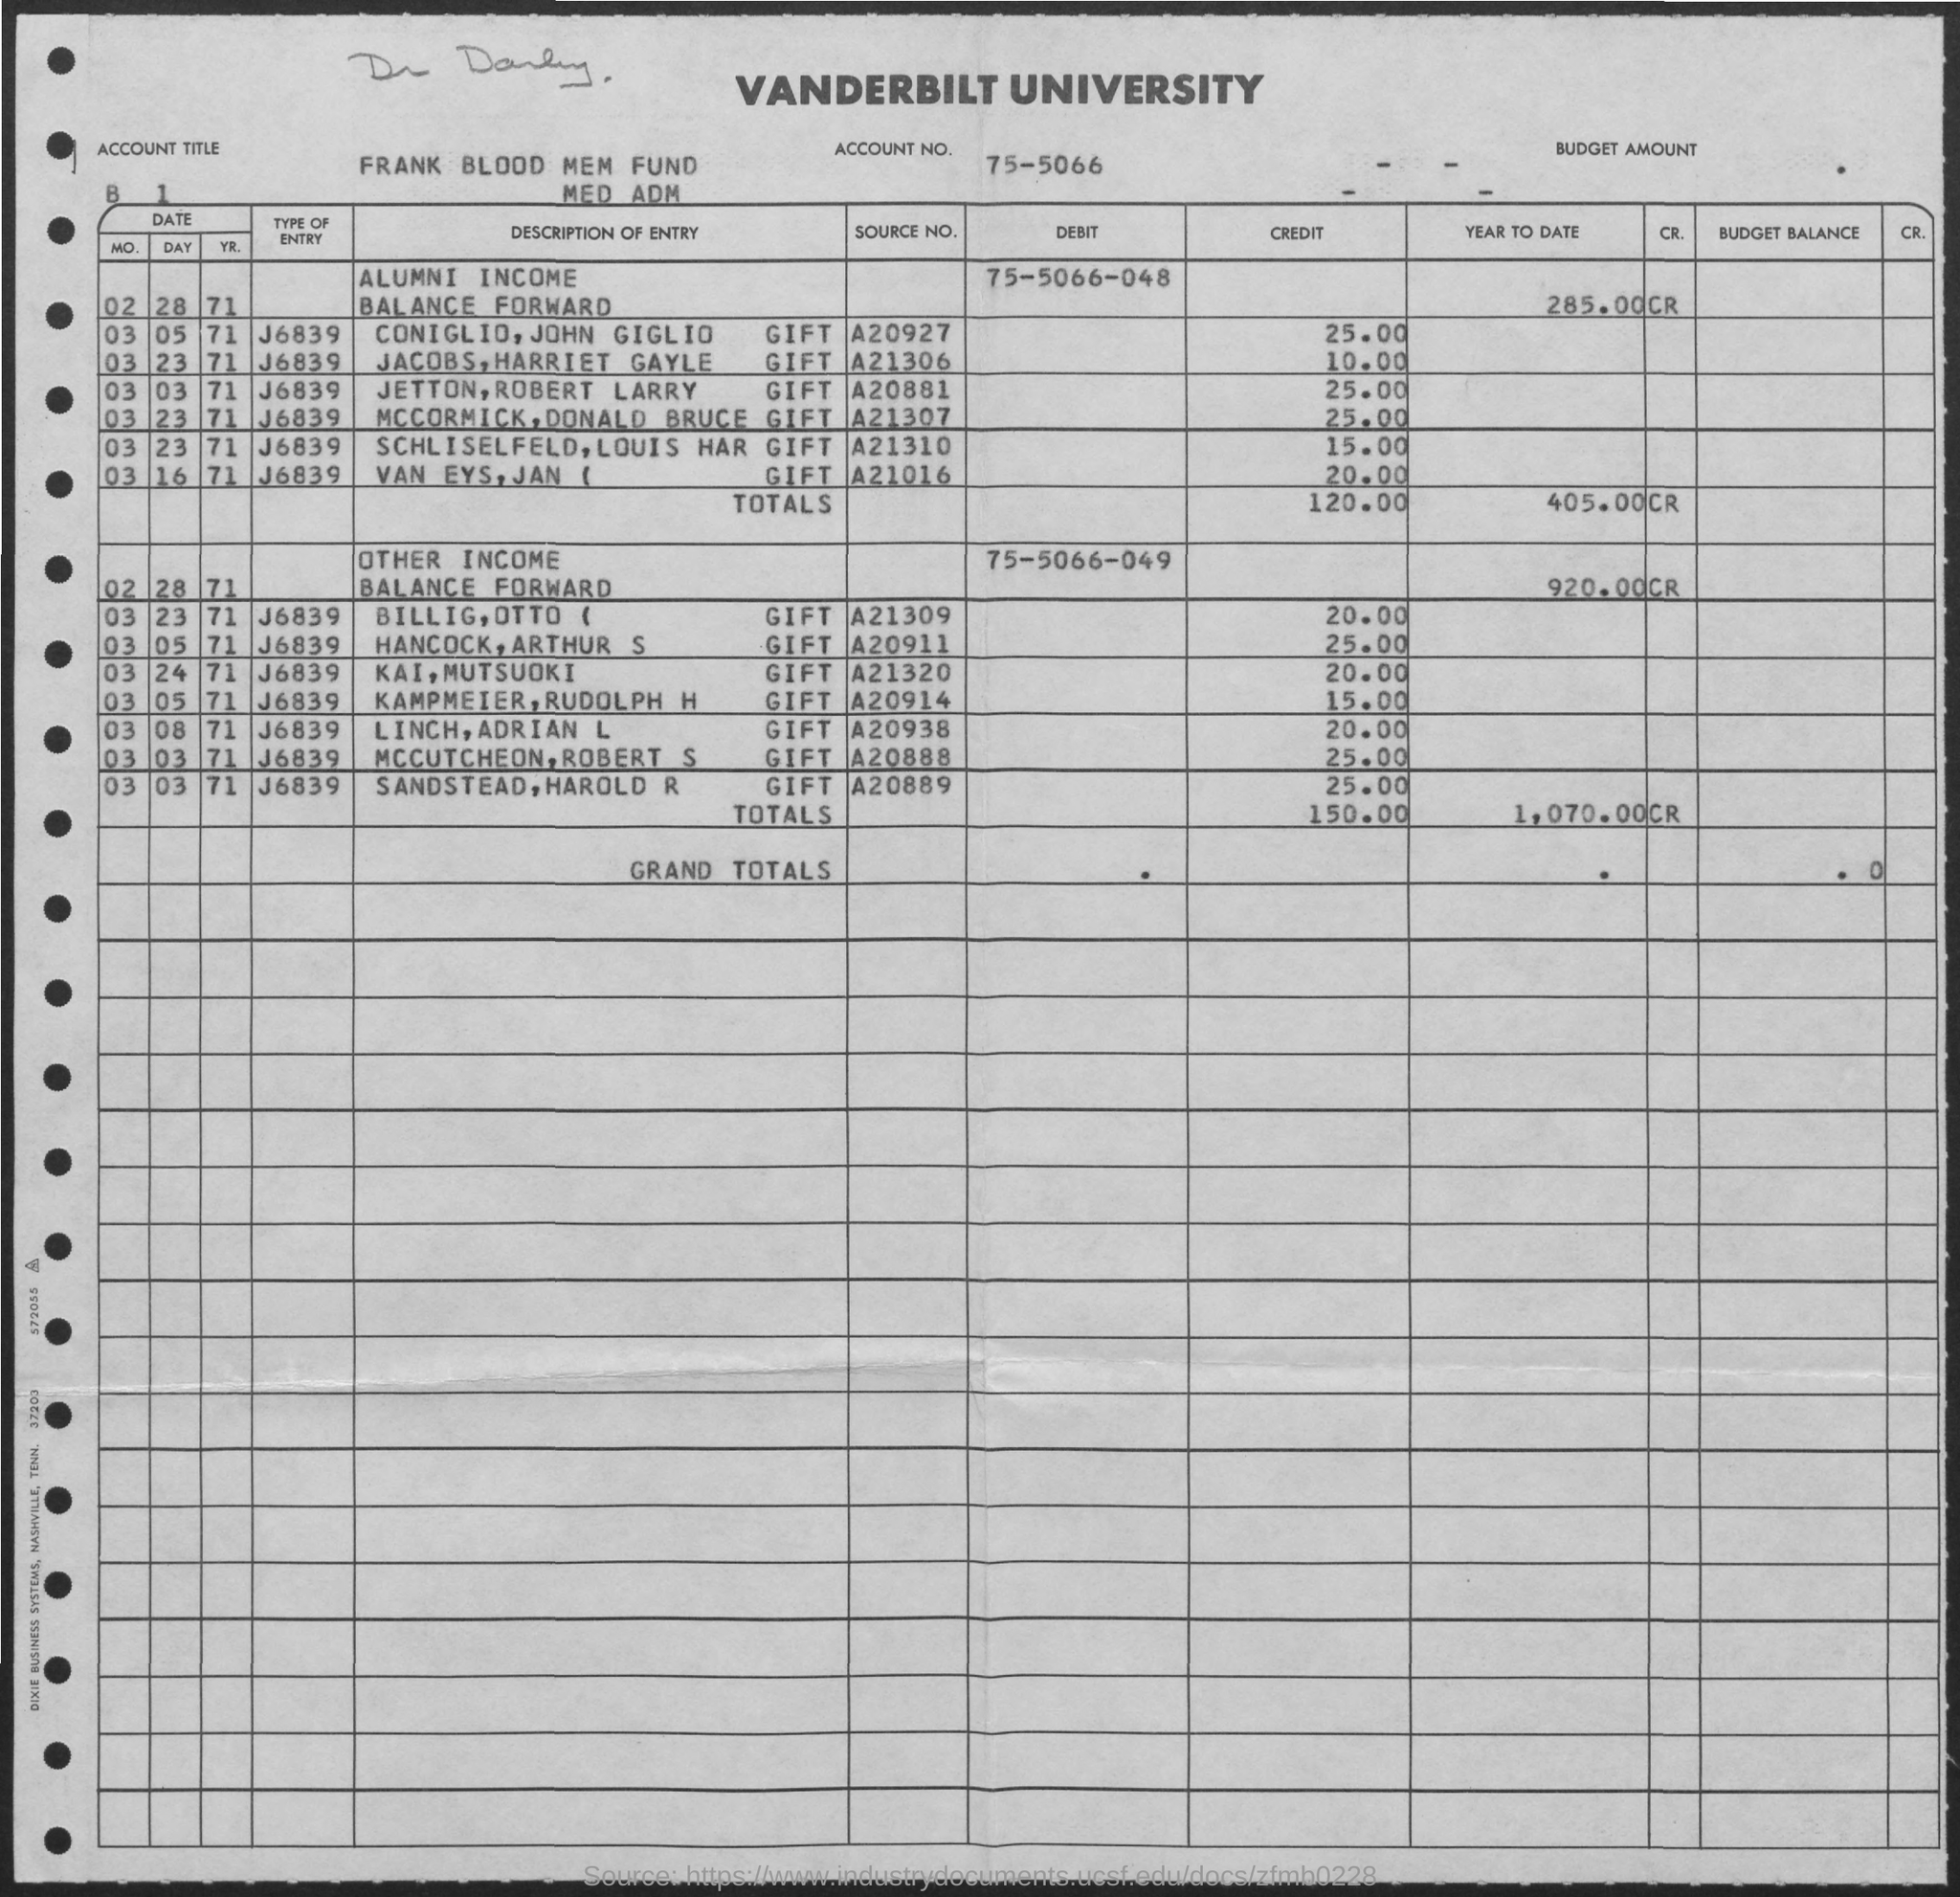Specify some key components in this picture. Please provide the account title as 'Frank Blood Mem Fund Med Adm.' Vanderbilt University is mentioned on the document. 